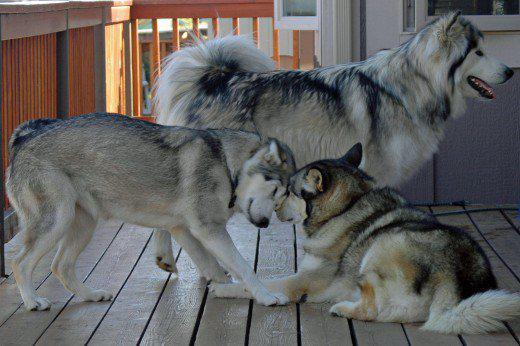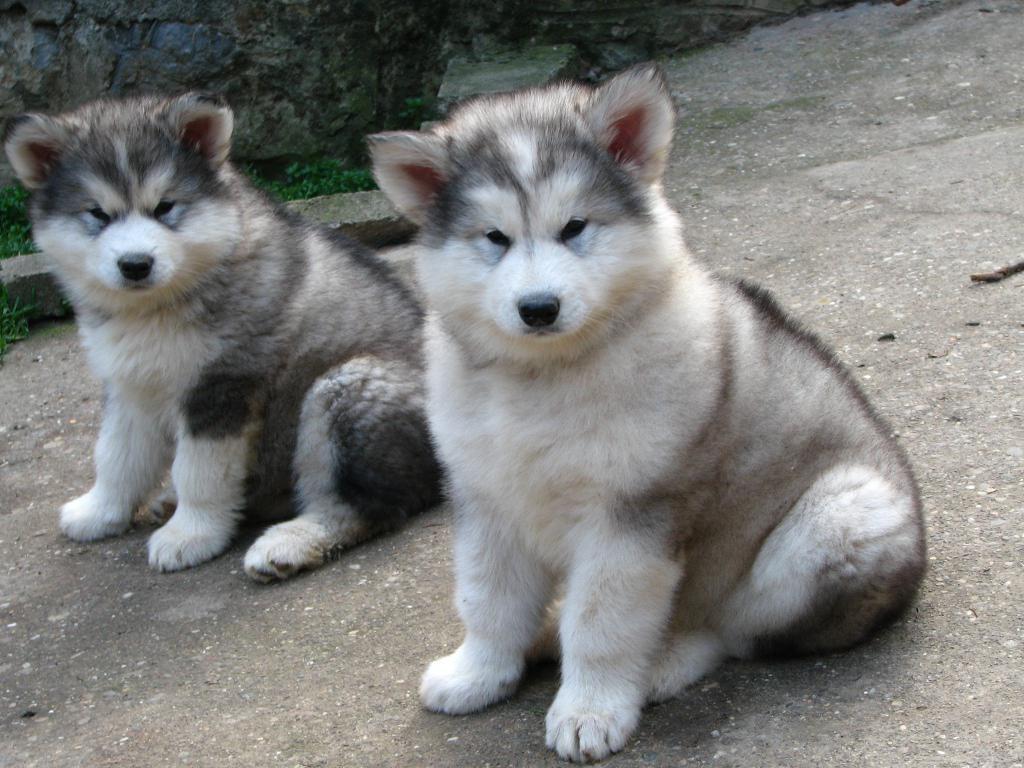The first image is the image on the left, the second image is the image on the right. Examine the images to the left and right. Is the description "There is freshly cut hair on the ground." accurate? Answer yes or no. No. The first image is the image on the left, the second image is the image on the right. Analyze the images presented: Is the assertion "Four or more dogs can be seen." valid? Answer yes or no. Yes. 